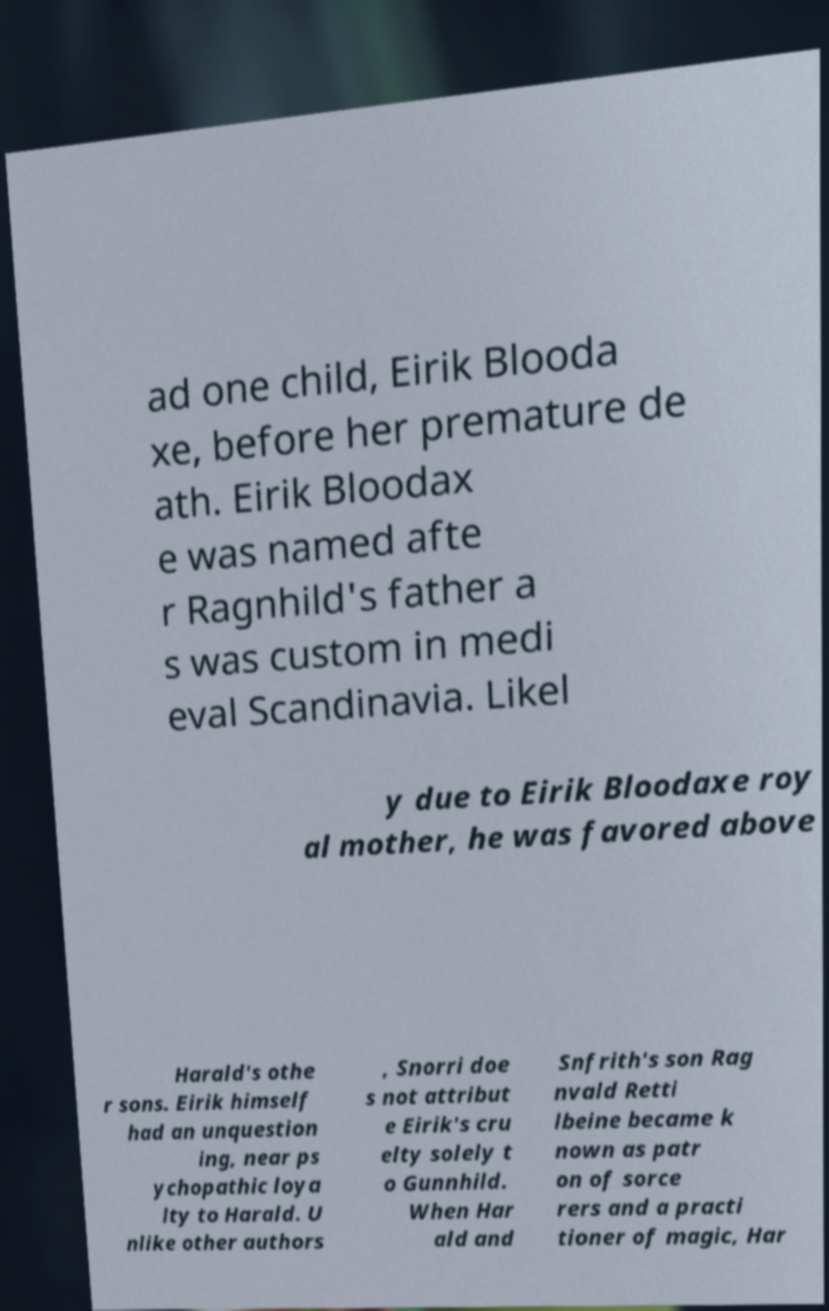Please identify and transcribe the text found in this image. ad one child, Eirik Blooda xe, before her premature de ath. Eirik Bloodax e was named afte r Ragnhild's father a s was custom in medi eval Scandinavia. Likel y due to Eirik Bloodaxe roy al mother, he was favored above Harald's othe r sons. Eirik himself had an unquestion ing, near ps ychopathic loya lty to Harald. U nlike other authors , Snorri doe s not attribut e Eirik's cru elty solely t o Gunnhild. When Har ald and Snfrith's son Rag nvald Retti lbeine became k nown as patr on of sorce rers and a practi tioner of magic, Har 